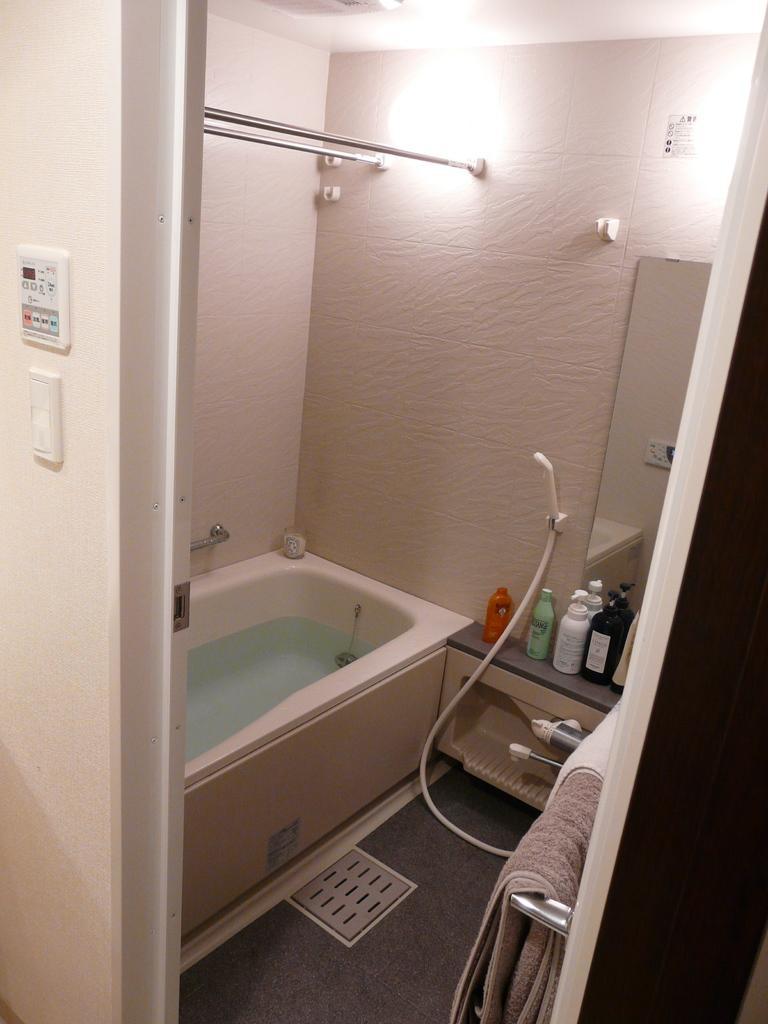Please provide a concise description of this image. This is a picture of a washroom, in this picture in the center there is a bath tub, pipe and some shampoo bottles, towels, mirror and some sticks and lights. And on the right side and left side there is a wall, on the wall there are some switch boards. At the bottom there is floor. 